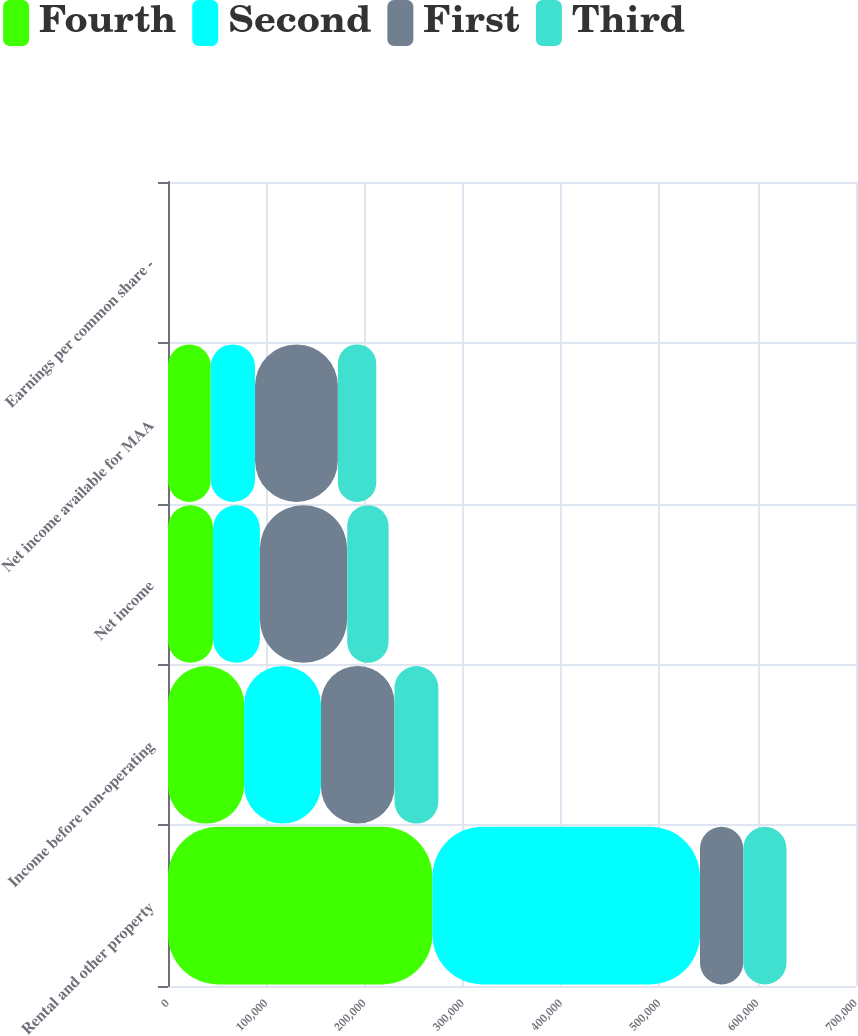<chart> <loc_0><loc_0><loc_500><loc_500><stacked_bar_chart><ecel><fcel>Rental and other property<fcel>Income before non-operating<fcel>Net income<fcel>Net income available for MAA<fcel>Earnings per common share -<nl><fcel>Fourth<fcel>269016<fcel>77422<fcel>45808<fcel>43413<fcel>0.58<nl><fcel>Second<fcel>272236<fcel>78215<fcel>47630<fcel>45144<fcel>0.6<nl><fcel>First<fcel>44015.5<fcel>74823<fcel>88906<fcel>84279<fcel>1.12<nl><fcel>Third<fcel>44015.5<fcel>44618<fcel>42058<fcel>39079<fcel>0.44<nl></chart> 